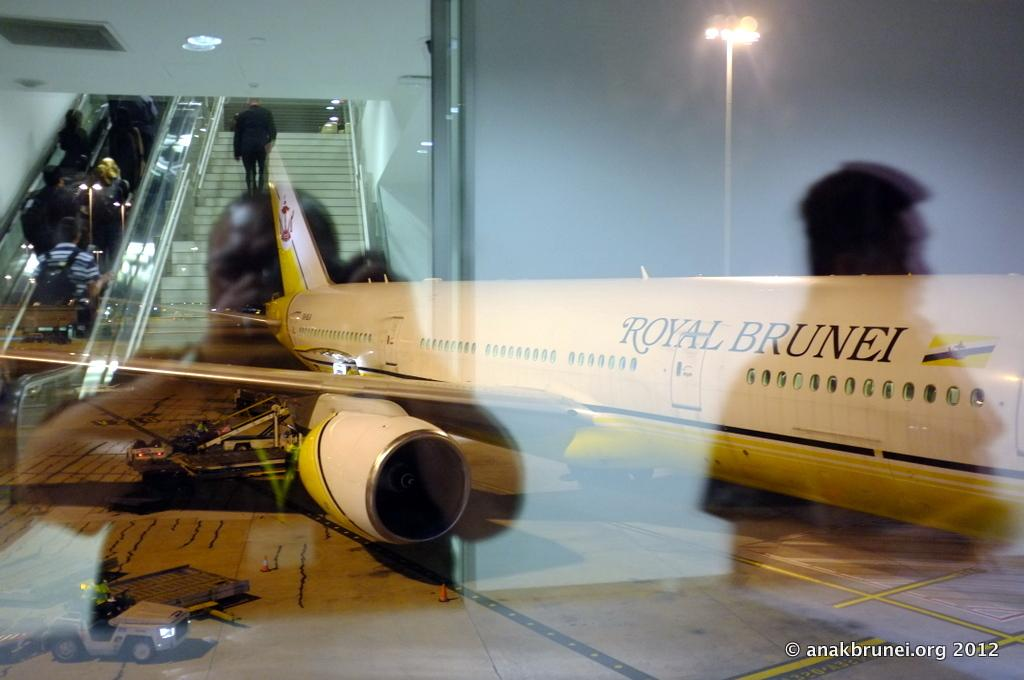Provide a one-sentence caption for the provided image. A Royal Brunei plane sits on the runway at night. 